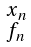<formula> <loc_0><loc_0><loc_500><loc_500>\begin{smallmatrix} x _ { n } \\ f _ { n } \end{smallmatrix}</formula> 